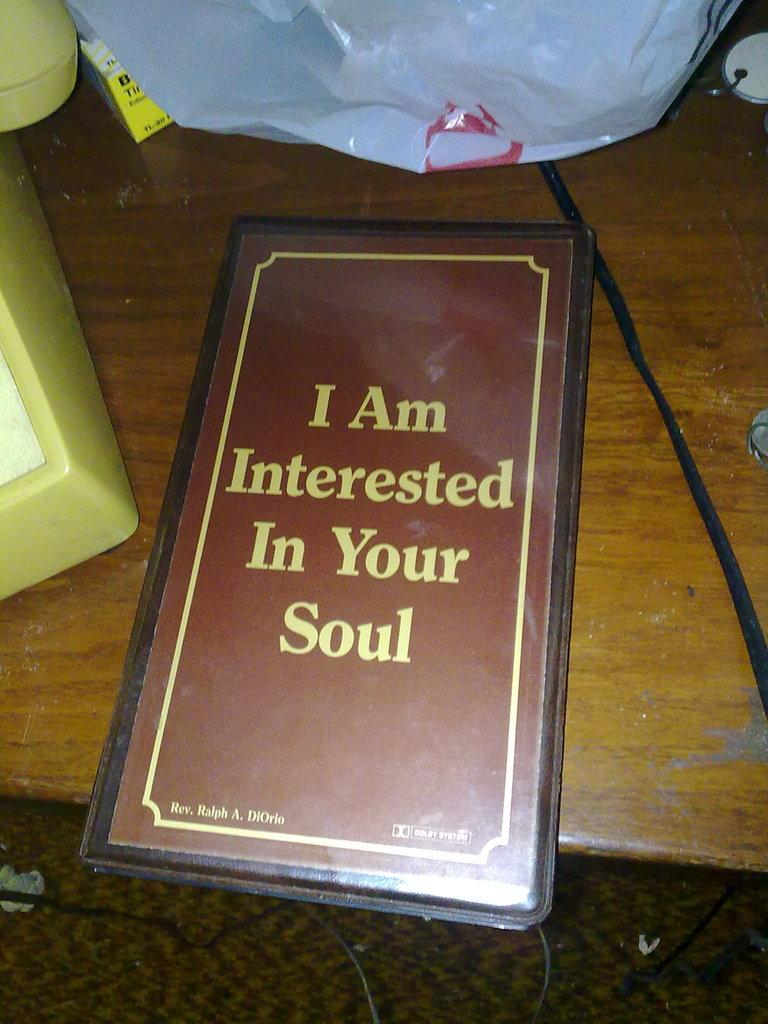<image>
Render a clear and concise summary of the photo. a menu on the table that says 'i am interested in your soul' 